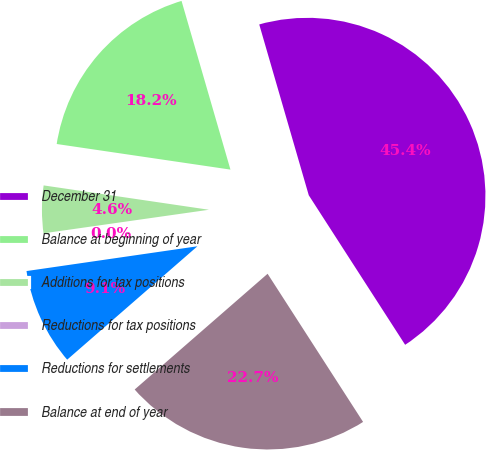Convert chart. <chart><loc_0><loc_0><loc_500><loc_500><pie_chart><fcel>December 31<fcel>Balance at beginning of year<fcel>Additions for tax positions<fcel>Reductions for tax positions<fcel>Reductions for settlements<fcel>Balance at end of year<nl><fcel>45.38%<fcel>18.18%<fcel>4.58%<fcel>0.04%<fcel>9.11%<fcel>22.71%<nl></chart> 